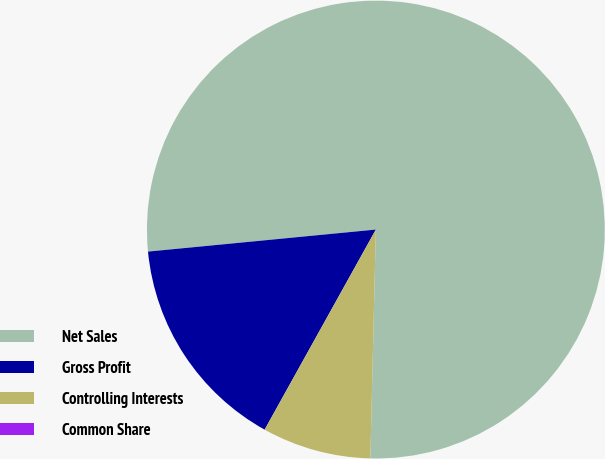<chart> <loc_0><loc_0><loc_500><loc_500><pie_chart><fcel>Net Sales<fcel>Gross Profit<fcel>Controlling Interests<fcel>Common Share<nl><fcel>76.92%<fcel>15.39%<fcel>7.69%<fcel>0.0%<nl></chart> 